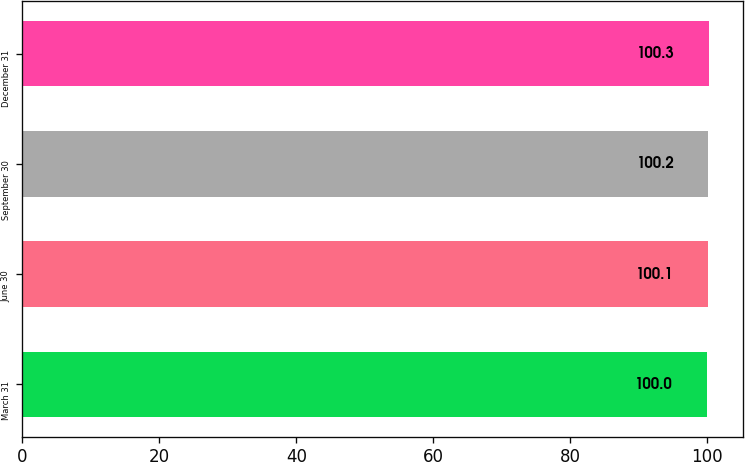<chart> <loc_0><loc_0><loc_500><loc_500><bar_chart><fcel>March 31<fcel>June 30<fcel>September 30<fcel>December 31<nl><fcel>100<fcel>100.1<fcel>100.2<fcel>100.3<nl></chart> 